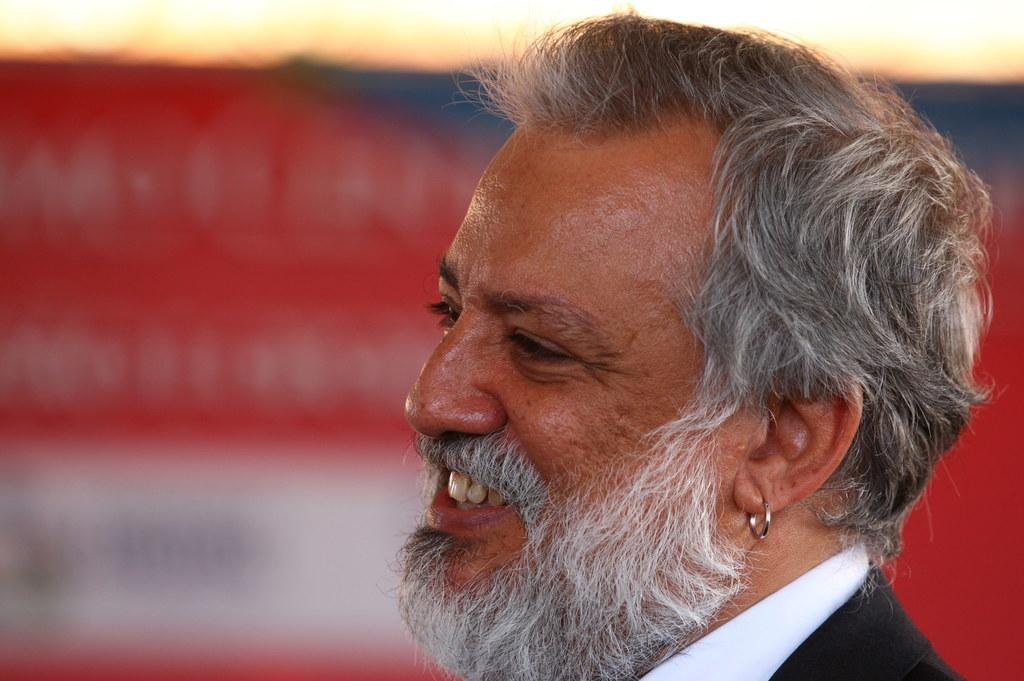Can you describe this image briefly? In this image we can see a man smiling. In the background there is a board. 